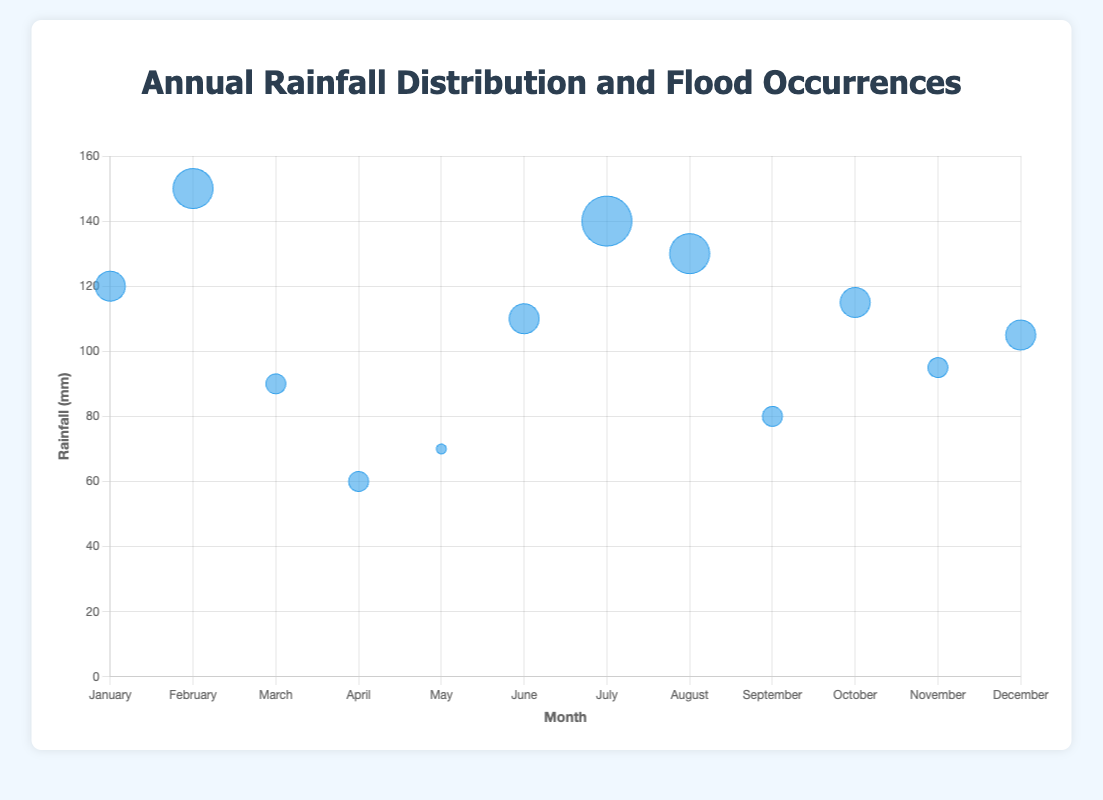How many months show at least two flood occurrences? By looking at the sizes of the bubbles, we observe that bubbles with at least two flood occurrences have larger sizes. The months with two or more flood occurrences are January, February, June, July, August, October, and December.
Answer: 7 Which month has the highest rainfall? The highest point on the y-axis represents the month with the highest rainfall. February, with 150 mm of rainfall, is the highest point.
Answer: February What is the total rainfall for the year? Sum up the rainfall amounts for all months: 120 + 150 + 90 + 60 + 70 + 110 + 140 + 130 + 80 + 115 + 95 + 105 = 1265 mm.
Answer: 1265 mm Which month has the most flood occurrences? The largest bubble corresponds to the month with the most flood occurrences. July has the largest bubble, indicating 4 occurrences.
Answer: July What is the average rainfall in the first quarter (January-March)? Calculate the average by summing the rainfall for January, February, and March, then dividing by 3: (120 + 150 + 90) / 3 = 360 / 3 = 120 mm.
Answer: 120 mm Is there a month with a high rainfall but no flood occurrence? By checking for months where the bubble radius indicates no flood occurrences, May has 70 mm of rainfall with 0 flood occurrences.
Answer: May Compare the rainfall amounts of June and September. Locate June and September on the figure and compare their positions on the y-axis. June has 110 mm of rainfall, whereas September has 80 mm.
Answer: June has more Which month has the same number of flood occurrences as March but different rainfall amounts? March has 1 flood occurrence. Looking for other bubbles with 1 flood occurrence and comparing rainfall amounts, April and September both have 1 flood occurrence, but different rainfall amounts of 60 mm and 80 mm respectively.
Answer: April, September Does a higher amount of rainfall always result in more flood occurrences? Observe the relationship between the bubble sizes and rainfall amounts. Although higher rainfall months tend to have more flood occurrences, it is not always true as seen by May (70 mm, 0 floods) and June (110 mm, 2 floods).
Answer: No What is the combined rainfall of the months with exactly 3 flood occurrences? Sum the rainfall amounts for February (150 mm) and August (130 mm) which have exactly 3 flood occurrences: 150 + 130 = 280 mm.
Answer: 280 mm 